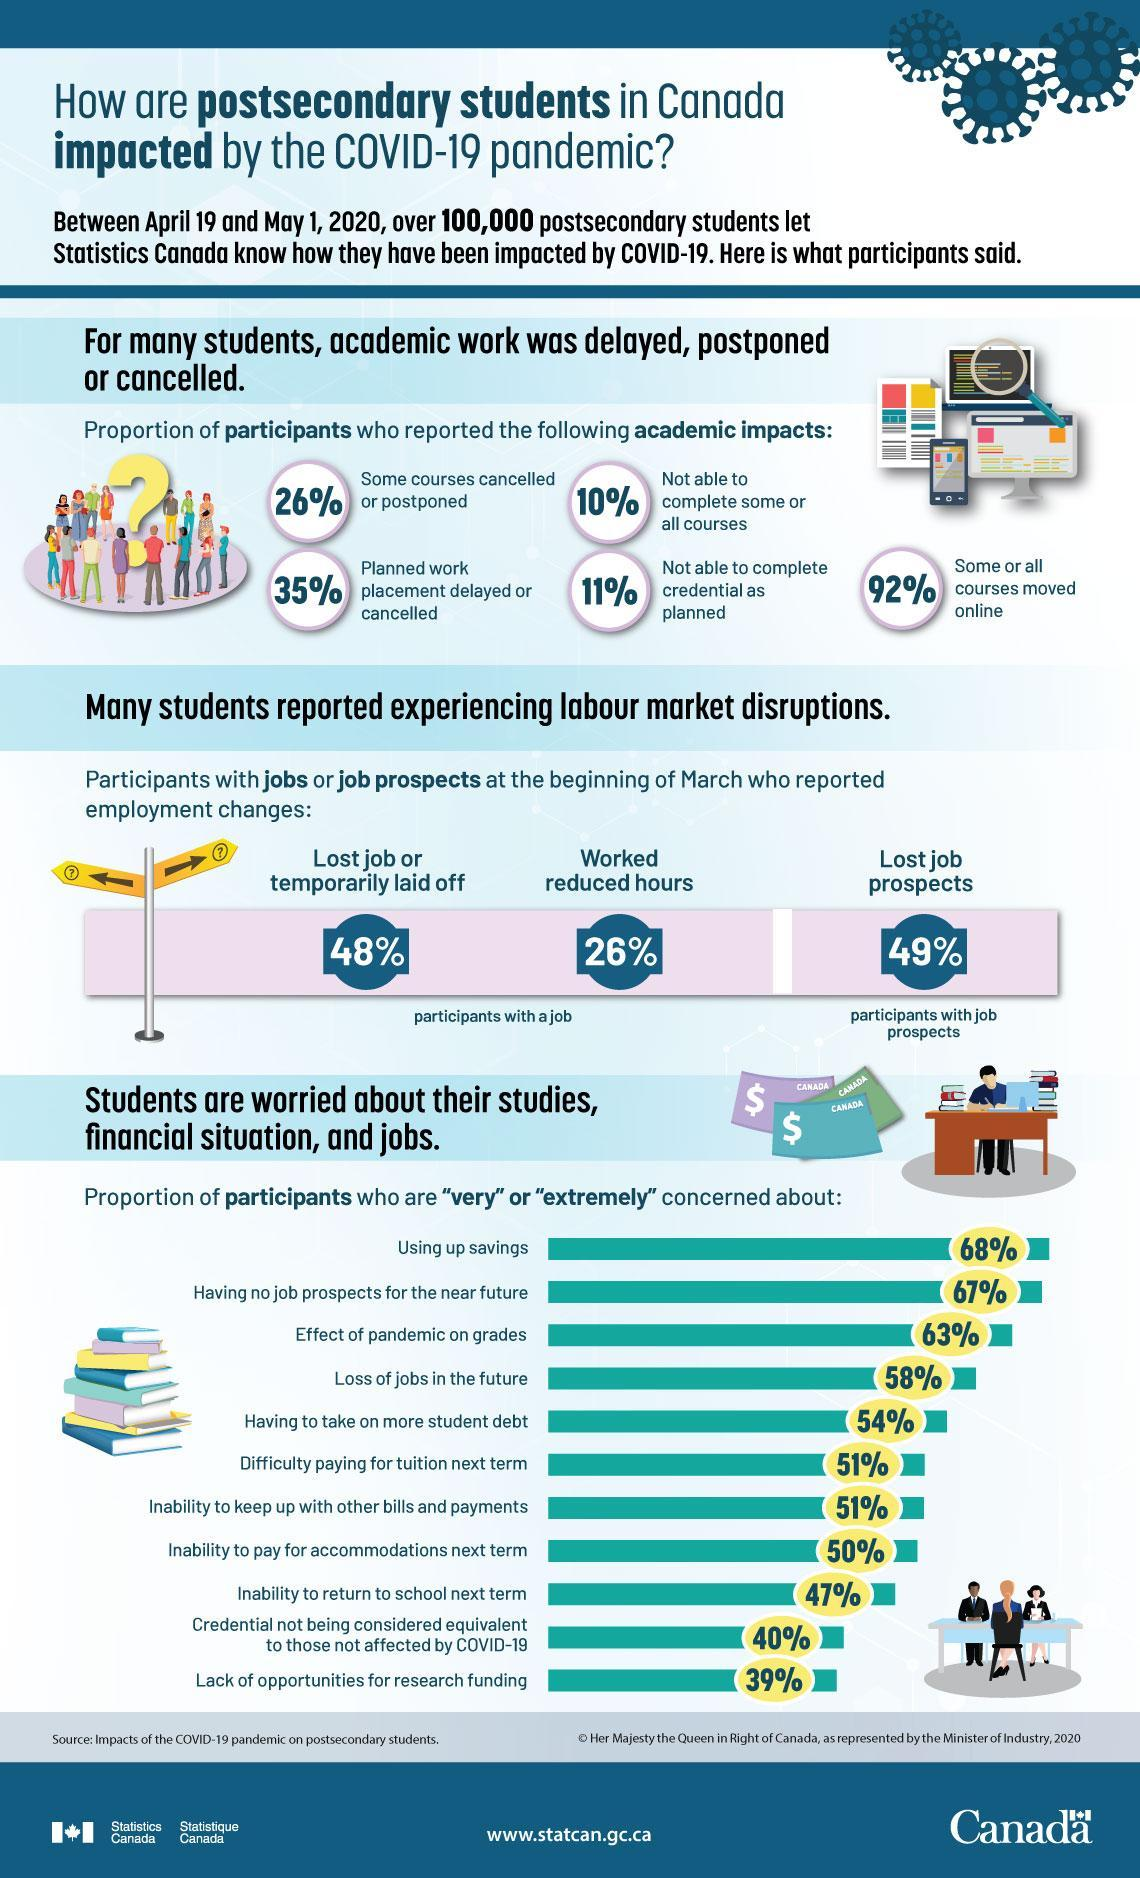How many of the participants worked for lesser hours?
Answer the question with a short phrase. 26% How many participants were not worried about savings being used up? 32% How many participants were not worried about being able to return to school the next term? 53% How many participants lost job prospects due to COVID-19 pandemic? 49% How many of the participants reported about inability to complete the academic courses due to the pandemic situation? 10% What was the major reason of extreme concern for most of the participants? Using up savings How many of the participants lost job or were temporarily laid off? 48% How many of the participants reported about shifting of courses online? 92% 